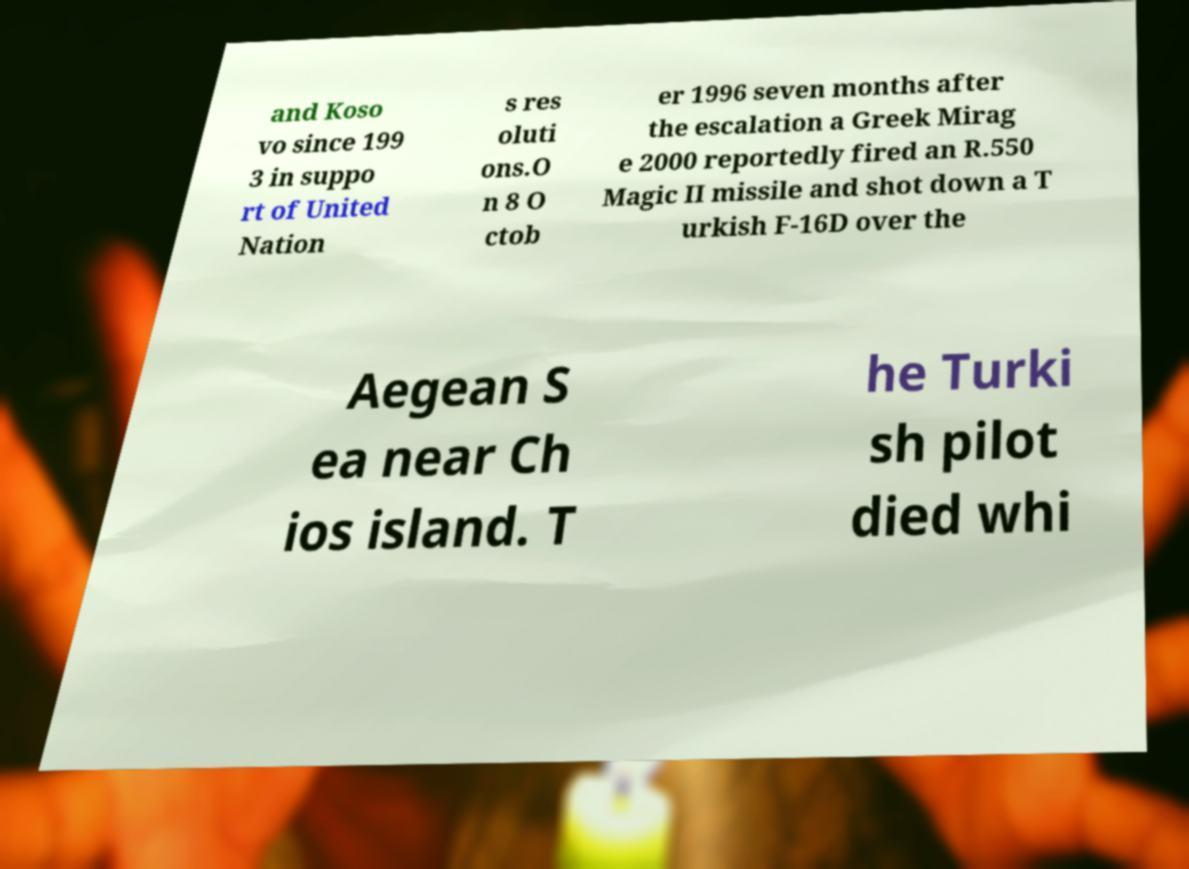Please read and relay the text visible in this image. What does it say? and Koso vo since 199 3 in suppo rt of United Nation s res oluti ons.O n 8 O ctob er 1996 seven months after the escalation a Greek Mirag e 2000 reportedly fired an R.550 Magic II missile and shot down a T urkish F-16D over the Aegean S ea near Ch ios island. T he Turki sh pilot died whi 